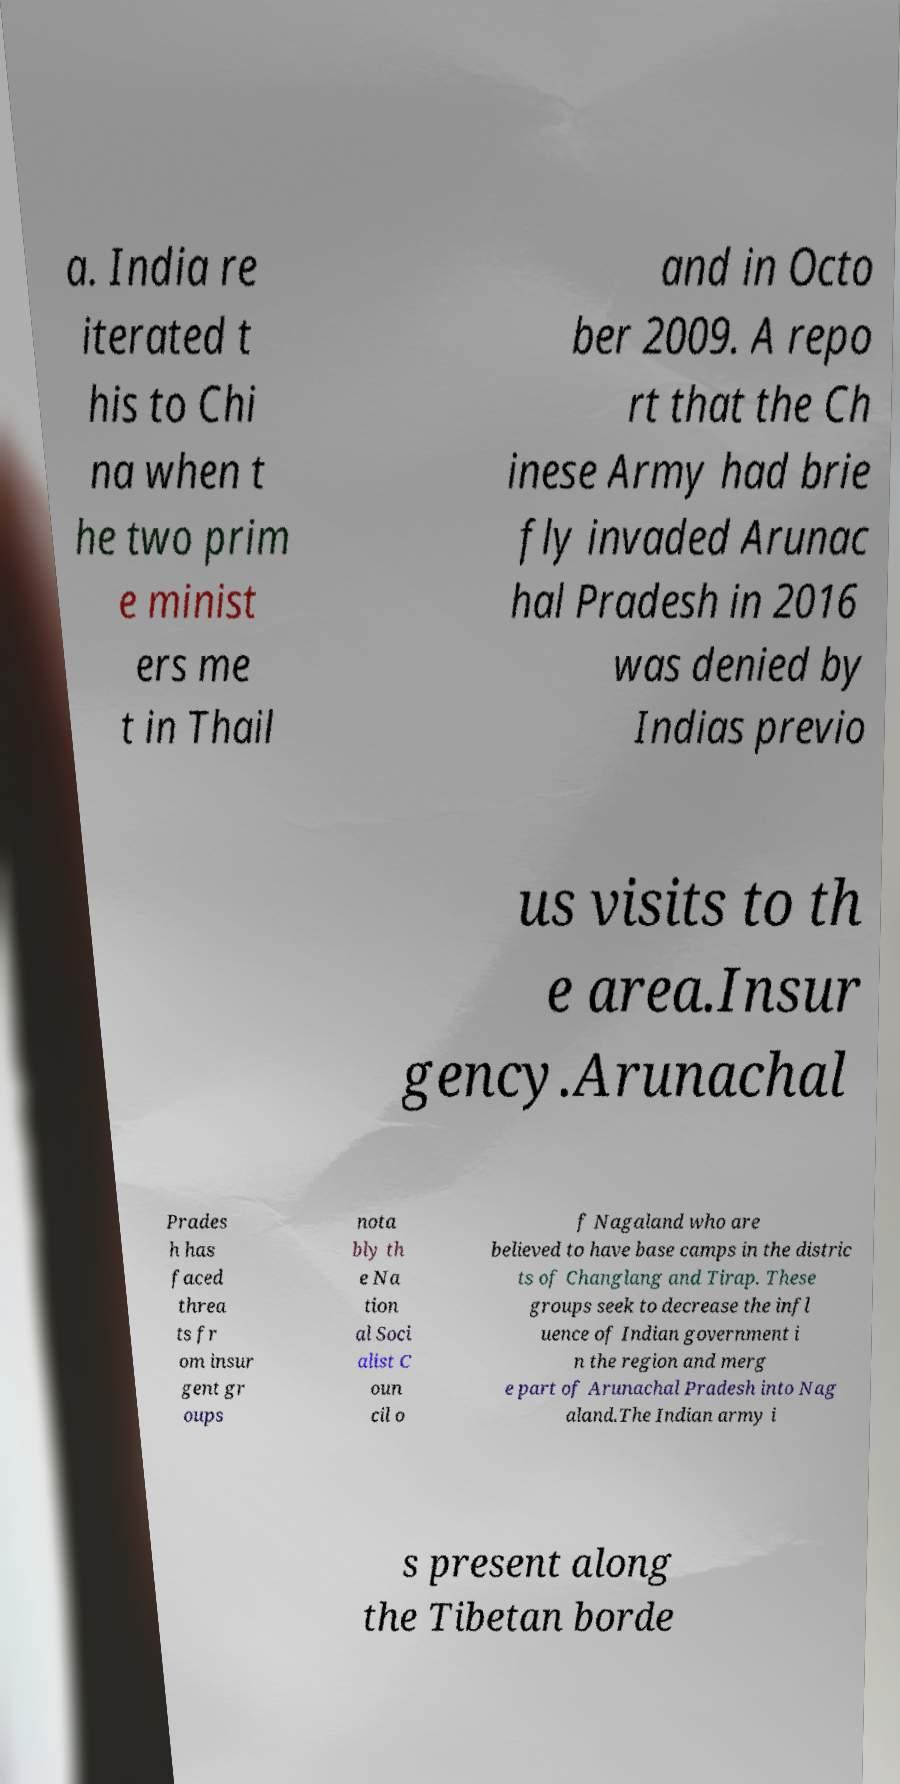There's text embedded in this image that I need extracted. Can you transcribe it verbatim? a. India re iterated t his to Chi na when t he two prim e minist ers me t in Thail and in Octo ber 2009. A repo rt that the Ch inese Army had brie fly invaded Arunac hal Pradesh in 2016 was denied by Indias previo us visits to th e area.Insur gency.Arunachal Prades h has faced threa ts fr om insur gent gr oups nota bly th e Na tion al Soci alist C oun cil o f Nagaland who are believed to have base camps in the distric ts of Changlang and Tirap. These groups seek to decrease the infl uence of Indian government i n the region and merg e part of Arunachal Pradesh into Nag aland.The Indian army i s present along the Tibetan borde 